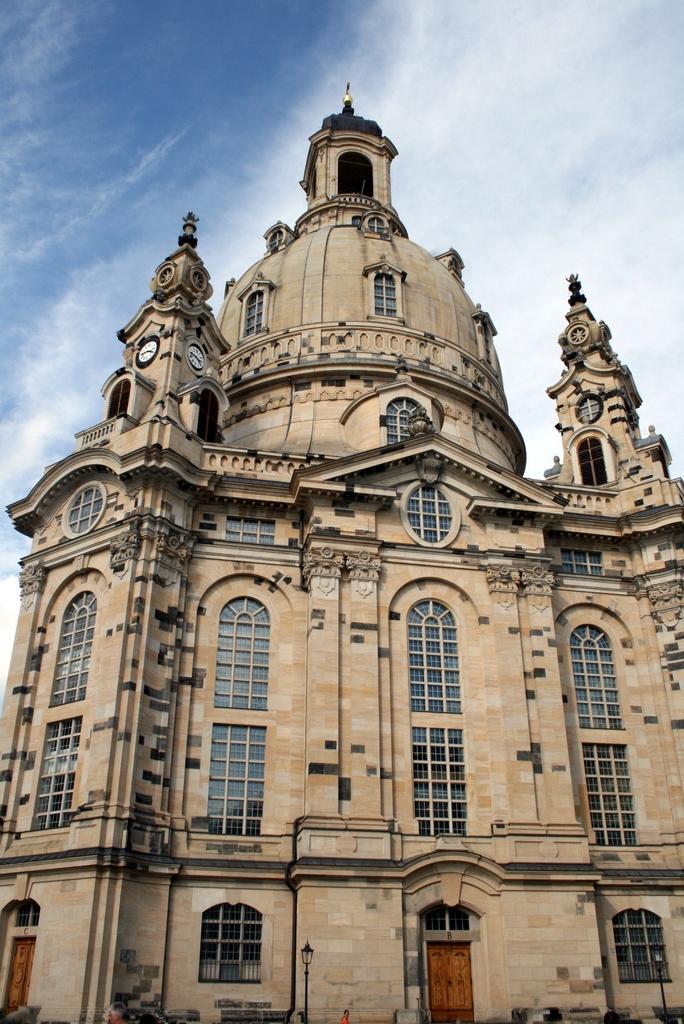Please provide a concise description of this image. In the image there is a building with pillars, walls, glass windows and doors. In front of the building there is a pole with lamp. And also to the pillars of the buildings there are clocks. And to the top of the image in the background there is a sky. 